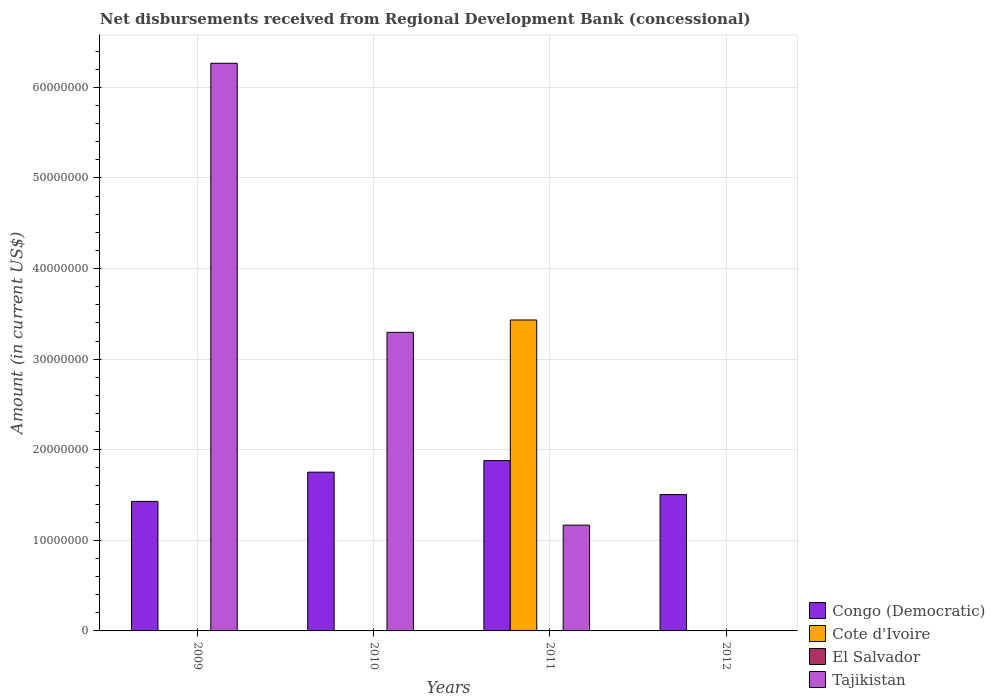Are the number of bars per tick equal to the number of legend labels?
Your answer should be very brief. No. Are the number of bars on each tick of the X-axis equal?
Ensure brevity in your answer.  No. How many bars are there on the 2nd tick from the right?
Offer a very short reply. 3. In how many cases, is the number of bars for a given year not equal to the number of legend labels?
Provide a short and direct response. 4. What is the amount of disbursements received from Regional Development Bank in Congo (Democratic) in 2010?
Offer a terse response. 1.75e+07. Across all years, what is the maximum amount of disbursements received from Regional Development Bank in Congo (Democratic)?
Your answer should be compact. 1.88e+07. In which year was the amount of disbursements received from Regional Development Bank in Cote d'Ivoire maximum?
Offer a terse response. 2011. What is the total amount of disbursements received from Regional Development Bank in Tajikistan in the graph?
Make the answer very short. 1.07e+08. What is the difference between the amount of disbursements received from Regional Development Bank in Tajikistan in 2009 and that in 2010?
Give a very brief answer. 2.97e+07. What is the difference between the amount of disbursements received from Regional Development Bank in El Salvador in 2010 and the amount of disbursements received from Regional Development Bank in Cote d'Ivoire in 2009?
Give a very brief answer. 0. What is the average amount of disbursements received from Regional Development Bank in El Salvador per year?
Your answer should be compact. 0. In the year 2009, what is the difference between the amount of disbursements received from Regional Development Bank in Tajikistan and amount of disbursements received from Regional Development Bank in Congo (Democratic)?
Offer a very short reply. 4.84e+07. In how many years, is the amount of disbursements received from Regional Development Bank in Tajikistan greater than 44000000 US$?
Keep it short and to the point. 1. Is the difference between the amount of disbursements received from Regional Development Bank in Tajikistan in 2010 and 2011 greater than the difference between the amount of disbursements received from Regional Development Bank in Congo (Democratic) in 2010 and 2011?
Offer a very short reply. Yes. What is the difference between the highest and the second highest amount of disbursements received from Regional Development Bank in Tajikistan?
Your answer should be very brief. 2.97e+07. What is the difference between the highest and the lowest amount of disbursements received from Regional Development Bank in Tajikistan?
Keep it short and to the point. 6.27e+07. In how many years, is the amount of disbursements received from Regional Development Bank in Cote d'Ivoire greater than the average amount of disbursements received from Regional Development Bank in Cote d'Ivoire taken over all years?
Give a very brief answer. 1. Is the sum of the amount of disbursements received from Regional Development Bank in Tajikistan in 2010 and 2011 greater than the maximum amount of disbursements received from Regional Development Bank in Cote d'Ivoire across all years?
Provide a succinct answer. Yes. Is it the case that in every year, the sum of the amount of disbursements received from Regional Development Bank in Cote d'Ivoire and amount of disbursements received from Regional Development Bank in Tajikistan is greater than the sum of amount of disbursements received from Regional Development Bank in Congo (Democratic) and amount of disbursements received from Regional Development Bank in El Salvador?
Your answer should be very brief. No. Is it the case that in every year, the sum of the amount of disbursements received from Regional Development Bank in Congo (Democratic) and amount of disbursements received from Regional Development Bank in Cote d'Ivoire is greater than the amount of disbursements received from Regional Development Bank in Tajikistan?
Offer a terse response. No. Are all the bars in the graph horizontal?
Your response must be concise. No. How many years are there in the graph?
Offer a very short reply. 4. What is the difference between two consecutive major ticks on the Y-axis?
Your response must be concise. 1.00e+07. Are the values on the major ticks of Y-axis written in scientific E-notation?
Your answer should be very brief. No. Where does the legend appear in the graph?
Offer a very short reply. Bottom right. What is the title of the graph?
Your answer should be very brief. Net disbursements received from Regional Development Bank (concessional). Does "Palau" appear as one of the legend labels in the graph?
Offer a terse response. No. What is the label or title of the X-axis?
Offer a terse response. Years. What is the label or title of the Y-axis?
Give a very brief answer. Amount (in current US$). What is the Amount (in current US$) in Congo (Democratic) in 2009?
Your answer should be very brief. 1.43e+07. What is the Amount (in current US$) of Cote d'Ivoire in 2009?
Make the answer very short. 0. What is the Amount (in current US$) of El Salvador in 2009?
Your answer should be compact. 0. What is the Amount (in current US$) of Tajikistan in 2009?
Your answer should be very brief. 6.27e+07. What is the Amount (in current US$) of Congo (Democratic) in 2010?
Provide a succinct answer. 1.75e+07. What is the Amount (in current US$) of Cote d'Ivoire in 2010?
Make the answer very short. 0. What is the Amount (in current US$) of Tajikistan in 2010?
Offer a very short reply. 3.30e+07. What is the Amount (in current US$) in Congo (Democratic) in 2011?
Give a very brief answer. 1.88e+07. What is the Amount (in current US$) of Cote d'Ivoire in 2011?
Provide a short and direct response. 3.43e+07. What is the Amount (in current US$) of Tajikistan in 2011?
Make the answer very short. 1.17e+07. What is the Amount (in current US$) of Congo (Democratic) in 2012?
Provide a succinct answer. 1.51e+07. What is the Amount (in current US$) in El Salvador in 2012?
Keep it short and to the point. 0. Across all years, what is the maximum Amount (in current US$) of Congo (Democratic)?
Make the answer very short. 1.88e+07. Across all years, what is the maximum Amount (in current US$) in Cote d'Ivoire?
Keep it short and to the point. 3.43e+07. Across all years, what is the maximum Amount (in current US$) in Tajikistan?
Offer a very short reply. 6.27e+07. Across all years, what is the minimum Amount (in current US$) of Congo (Democratic)?
Your response must be concise. 1.43e+07. What is the total Amount (in current US$) in Congo (Democratic) in the graph?
Provide a short and direct response. 6.57e+07. What is the total Amount (in current US$) in Cote d'Ivoire in the graph?
Your answer should be compact. 3.43e+07. What is the total Amount (in current US$) in El Salvador in the graph?
Provide a succinct answer. 0. What is the total Amount (in current US$) in Tajikistan in the graph?
Provide a short and direct response. 1.07e+08. What is the difference between the Amount (in current US$) in Congo (Democratic) in 2009 and that in 2010?
Keep it short and to the point. -3.23e+06. What is the difference between the Amount (in current US$) of Tajikistan in 2009 and that in 2010?
Offer a very short reply. 2.97e+07. What is the difference between the Amount (in current US$) of Congo (Democratic) in 2009 and that in 2011?
Make the answer very short. -4.50e+06. What is the difference between the Amount (in current US$) in Tajikistan in 2009 and that in 2011?
Your answer should be compact. 5.10e+07. What is the difference between the Amount (in current US$) in Congo (Democratic) in 2009 and that in 2012?
Offer a terse response. -7.55e+05. What is the difference between the Amount (in current US$) in Congo (Democratic) in 2010 and that in 2011?
Make the answer very short. -1.28e+06. What is the difference between the Amount (in current US$) in Tajikistan in 2010 and that in 2011?
Provide a short and direct response. 2.13e+07. What is the difference between the Amount (in current US$) of Congo (Democratic) in 2010 and that in 2012?
Provide a succinct answer. 2.47e+06. What is the difference between the Amount (in current US$) of Congo (Democratic) in 2011 and that in 2012?
Provide a short and direct response. 3.75e+06. What is the difference between the Amount (in current US$) of Congo (Democratic) in 2009 and the Amount (in current US$) of Tajikistan in 2010?
Ensure brevity in your answer.  -1.87e+07. What is the difference between the Amount (in current US$) of Congo (Democratic) in 2009 and the Amount (in current US$) of Cote d'Ivoire in 2011?
Give a very brief answer. -2.00e+07. What is the difference between the Amount (in current US$) of Congo (Democratic) in 2009 and the Amount (in current US$) of Tajikistan in 2011?
Provide a succinct answer. 2.62e+06. What is the difference between the Amount (in current US$) of Congo (Democratic) in 2010 and the Amount (in current US$) of Cote d'Ivoire in 2011?
Ensure brevity in your answer.  -1.68e+07. What is the difference between the Amount (in current US$) in Congo (Democratic) in 2010 and the Amount (in current US$) in Tajikistan in 2011?
Ensure brevity in your answer.  5.85e+06. What is the average Amount (in current US$) of Congo (Democratic) per year?
Keep it short and to the point. 1.64e+07. What is the average Amount (in current US$) of Cote d'Ivoire per year?
Offer a very short reply. 8.58e+06. What is the average Amount (in current US$) of El Salvador per year?
Give a very brief answer. 0. What is the average Amount (in current US$) in Tajikistan per year?
Provide a succinct answer. 2.68e+07. In the year 2009, what is the difference between the Amount (in current US$) in Congo (Democratic) and Amount (in current US$) in Tajikistan?
Ensure brevity in your answer.  -4.84e+07. In the year 2010, what is the difference between the Amount (in current US$) in Congo (Democratic) and Amount (in current US$) in Tajikistan?
Your answer should be compact. -1.54e+07. In the year 2011, what is the difference between the Amount (in current US$) of Congo (Democratic) and Amount (in current US$) of Cote d'Ivoire?
Ensure brevity in your answer.  -1.55e+07. In the year 2011, what is the difference between the Amount (in current US$) of Congo (Democratic) and Amount (in current US$) of Tajikistan?
Provide a short and direct response. 7.12e+06. In the year 2011, what is the difference between the Amount (in current US$) in Cote d'Ivoire and Amount (in current US$) in Tajikistan?
Your answer should be compact. 2.26e+07. What is the ratio of the Amount (in current US$) of Congo (Democratic) in 2009 to that in 2010?
Your answer should be compact. 0.82. What is the ratio of the Amount (in current US$) of Tajikistan in 2009 to that in 2010?
Keep it short and to the point. 1.9. What is the ratio of the Amount (in current US$) of Congo (Democratic) in 2009 to that in 2011?
Provide a short and direct response. 0.76. What is the ratio of the Amount (in current US$) of Tajikistan in 2009 to that in 2011?
Make the answer very short. 5.37. What is the ratio of the Amount (in current US$) in Congo (Democratic) in 2009 to that in 2012?
Offer a terse response. 0.95. What is the ratio of the Amount (in current US$) of Congo (Democratic) in 2010 to that in 2011?
Your answer should be very brief. 0.93. What is the ratio of the Amount (in current US$) in Tajikistan in 2010 to that in 2011?
Your response must be concise. 2.82. What is the ratio of the Amount (in current US$) in Congo (Democratic) in 2010 to that in 2012?
Offer a terse response. 1.16. What is the ratio of the Amount (in current US$) of Congo (Democratic) in 2011 to that in 2012?
Offer a terse response. 1.25. What is the difference between the highest and the second highest Amount (in current US$) in Congo (Democratic)?
Offer a terse response. 1.28e+06. What is the difference between the highest and the second highest Amount (in current US$) in Tajikistan?
Your answer should be very brief. 2.97e+07. What is the difference between the highest and the lowest Amount (in current US$) of Congo (Democratic)?
Keep it short and to the point. 4.50e+06. What is the difference between the highest and the lowest Amount (in current US$) of Cote d'Ivoire?
Give a very brief answer. 3.43e+07. What is the difference between the highest and the lowest Amount (in current US$) in Tajikistan?
Keep it short and to the point. 6.27e+07. 